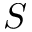Convert formula to latex. <formula><loc_0><loc_0><loc_500><loc_500>S</formula> 